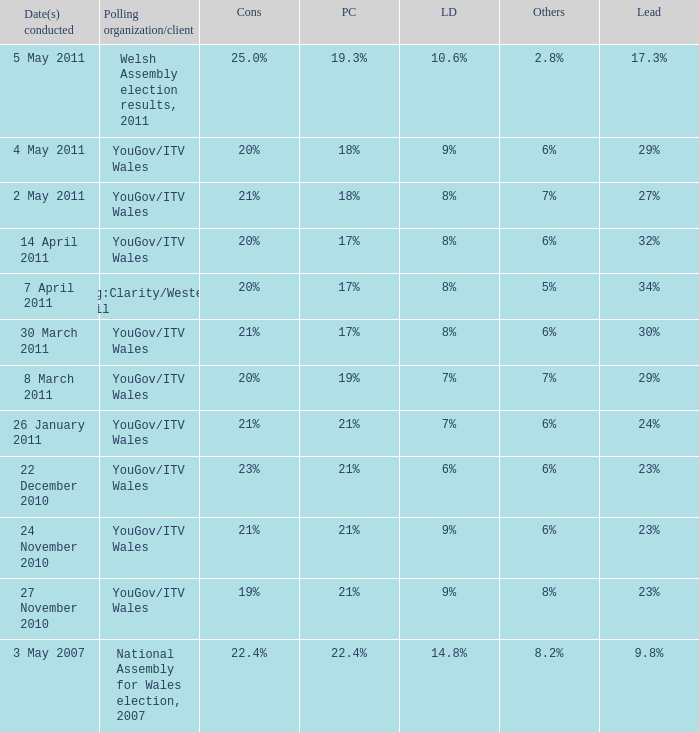Name the others for cons of 21% and lead of 24% 6%. 